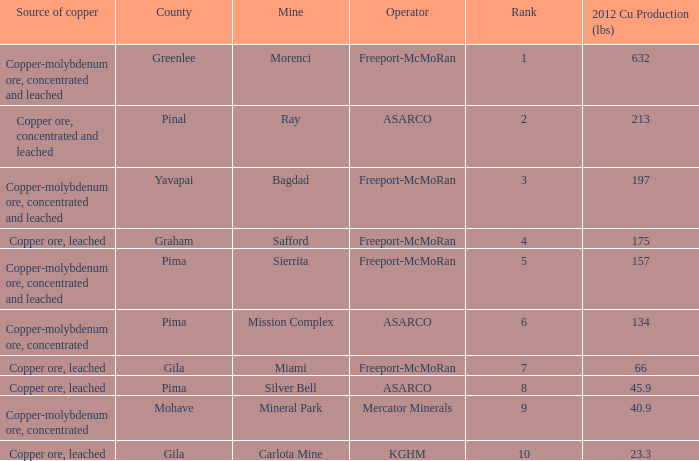Which operator has a rank of 7? Freeport-McMoRan. 